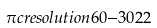Convert formula to latex. <formula><loc_0><loc_0><loc_500><loc_500>\pi c { r e s o l u t i o n } { 6 0 } { - 3 0 } { 2 } { 2 }</formula> 